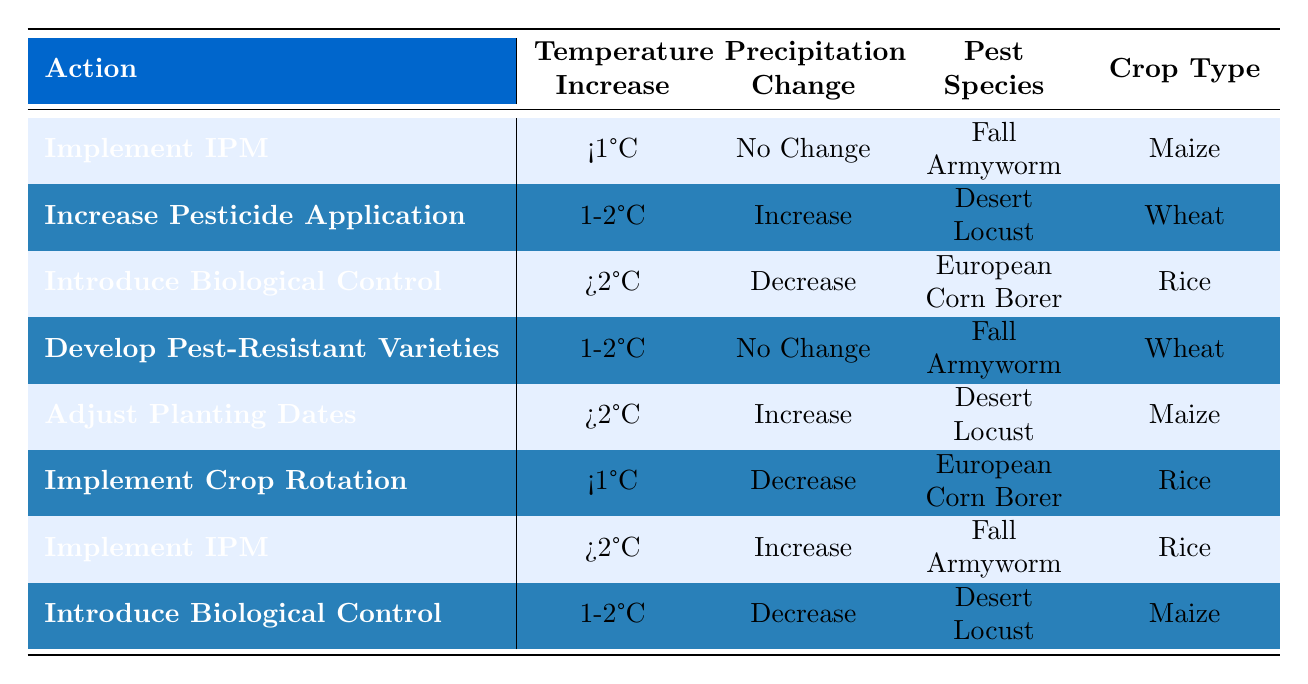What pest management action should be taken for Fall Armyworm on Maize when the temperature increases by less than 1°C and there is no change in precipitation? The table indicates that for the conditions of "<1°C", "No Change", "Fall Armyworm", and "Maize", the recommended action is to "Implement Integrated Pest Management (IPM)".
Answer: Implement Integrated Pest Management (IPM) What is the action recommended when the temperature increase is between 1-2°C and there is an increase in precipitation for Desert Locust on Wheat? According to the table, there is no entry for the conditions of "1-2°C", "Increase", "Desert Locust", and "Wheat", thus making it impossible to recommend an action for this specific scenario from the table.
Answer: No action recommended Is it true that introducing biological control agents is a recommended action for European Corn Borer on Rice when precipitation decreases and the temperature exceeds 2°C? The table shows that "Introduce Biological Control Agents" is applicable for "European Corn Borer" and "Rice" conditions only when temperature conditions exceed ">2°C" and precipitation has "Decrease". Therefore, this statement is true.
Answer: True What pest management actions are recommended for Desert Locust on Maize given the following conditions: 1-2°C temperature increase and no change in precipitation? The table does not provide a specific action for "Desert Locust", "Maize", with "1-2°C" increase and "No Change" precipitation. Therefore, there is no action available for these conditions in the table.
Answer: No action recommended If the average temperature increase for the scenarios in the table is calculated, what is the average? To find the average we sum the temperature increases considering the weight of applicable scenarios. The unique temperatures are <1°C (count = 2), 1-2°C (count = 3), >2°C (count = 3). So, Average = (0.5*2 + 1.5*3 + 2.5*3) / 8 = 1.5.
Answer: 1.5°C What is the action for Fall Armyworm when the temperature increase is more than 2°C and precipitation increases? The table indicates that if the conditions are ">2°C", "Increase", "Fall Armyworm", and "Rice", the action is to "Implement Integrated Pest Management (IPM)".
Answer: Implement Integrated Pest Management (IPM) 